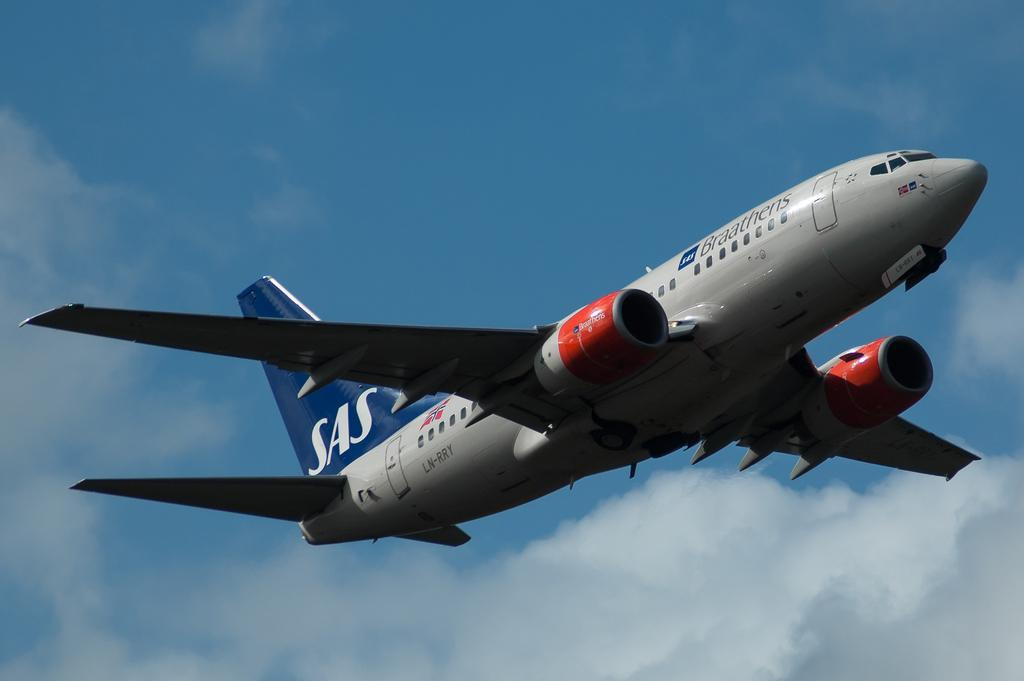What can be seen in the sky in the background of the image? There are clouds in the sky in the background of the image. What is flying in the air in the image? There is an airplane in the air in the image. How many eyes can be seen on the airplane in the image? There are no eyes visible on the airplane in the image, as airplanes do not have eyes. Is there a tent visible in the image? No, there is no tent present in the image. 